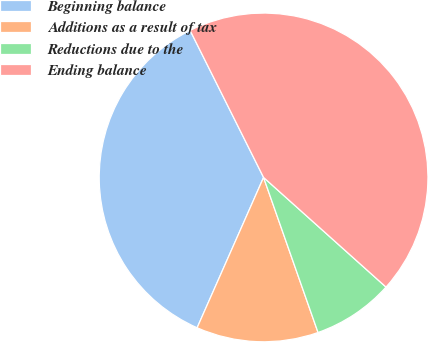Convert chart to OTSL. <chart><loc_0><loc_0><loc_500><loc_500><pie_chart><fcel>Beginning balance<fcel>Additions as a result of tax<fcel>Reductions due to the<fcel>Ending balance<nl><fcel>36.0%<fcel>12.0%<fcel>8.0%<fcel>44.0%<nl></chart> 